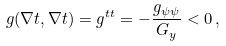Convert formula to latex. <formula><loc_0><loc_0><loc_500><loc_500>g ( \nabla t , \nabla t ) = g ^ { t t } = - \frac { g _ { \psi \psi } } { G _ { y } } < 0 \, ,</formula> 